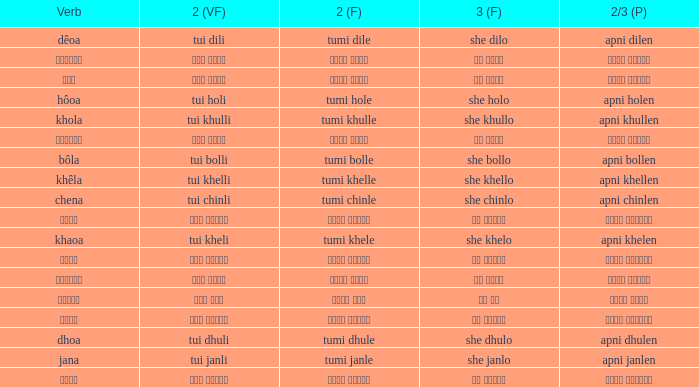What is the 2nd verb for Khola? Tumi khulle. 